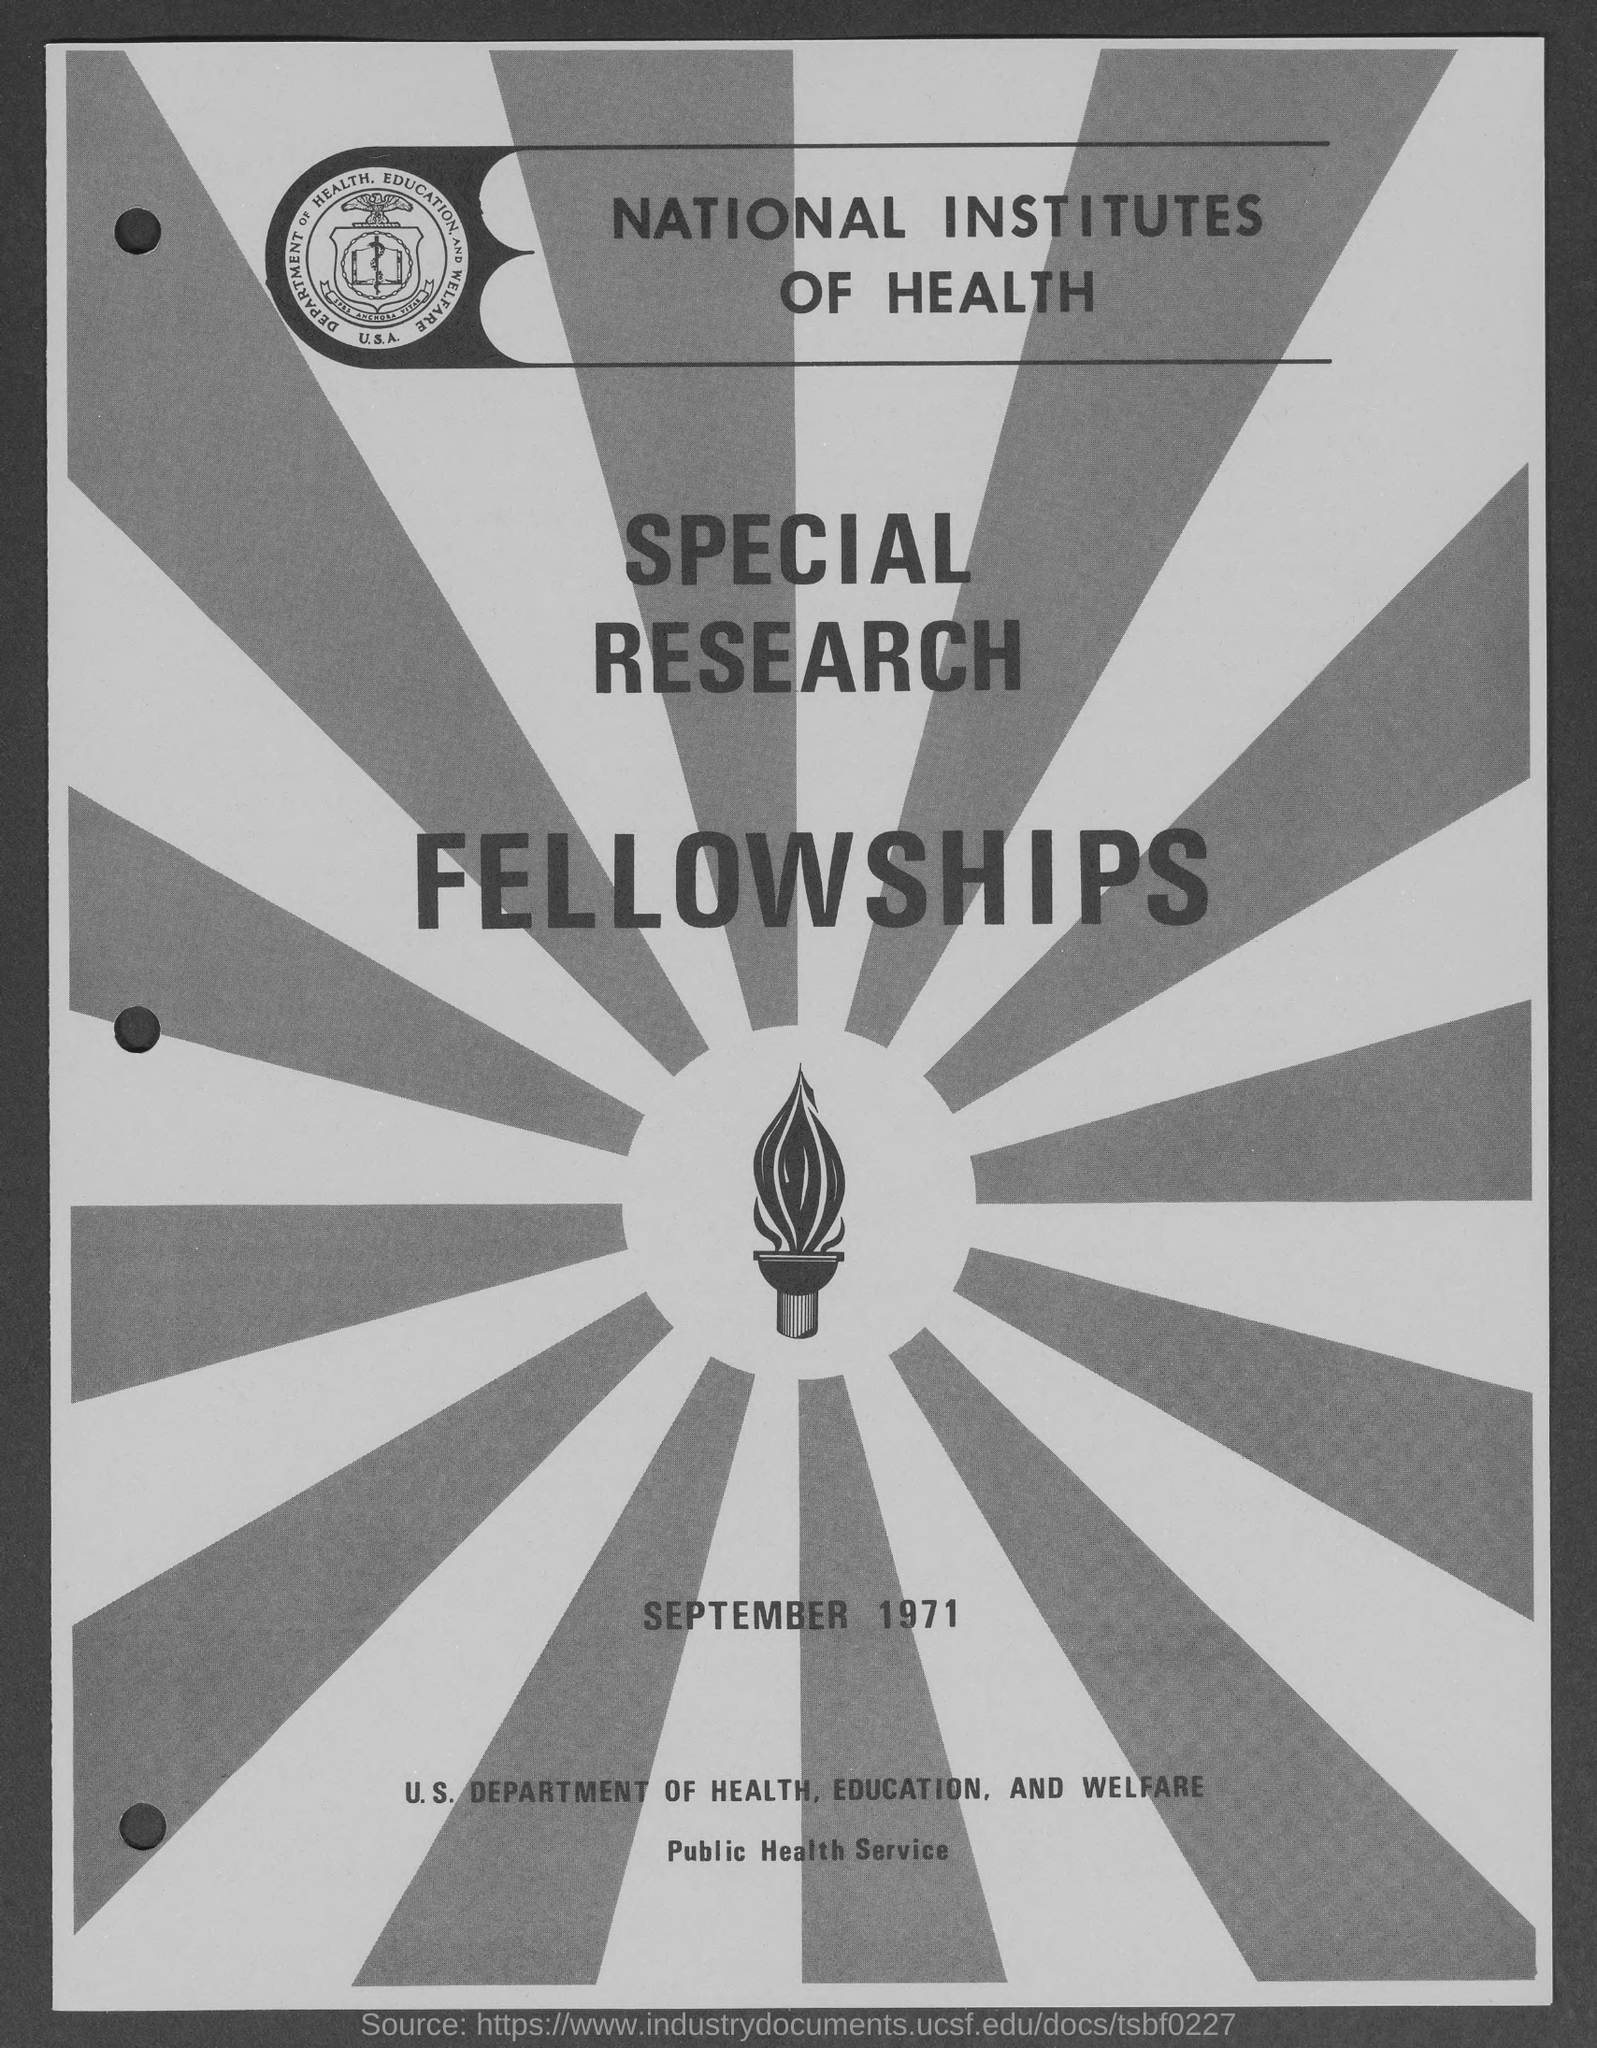What is the date mentioned in this document?
Your answer should be compact. September 1971. Which Institute's Special Research Fellowships is given here?
Keep it short and to the point. National institutes of health. 